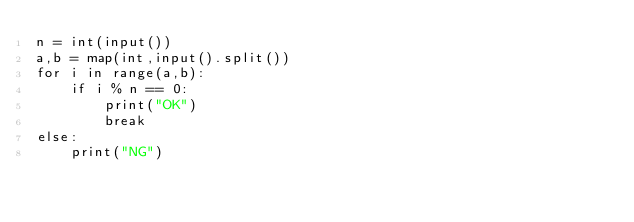Convert code to text. <code><loc_0><loc_0><loc_500><loc_500><_Python_>n = int(input())
a,b = map(int,input().split())
for i in range(a,b):
    if i % n == 0:
        print("OK")
        break
else:
    print("NG")</code> 